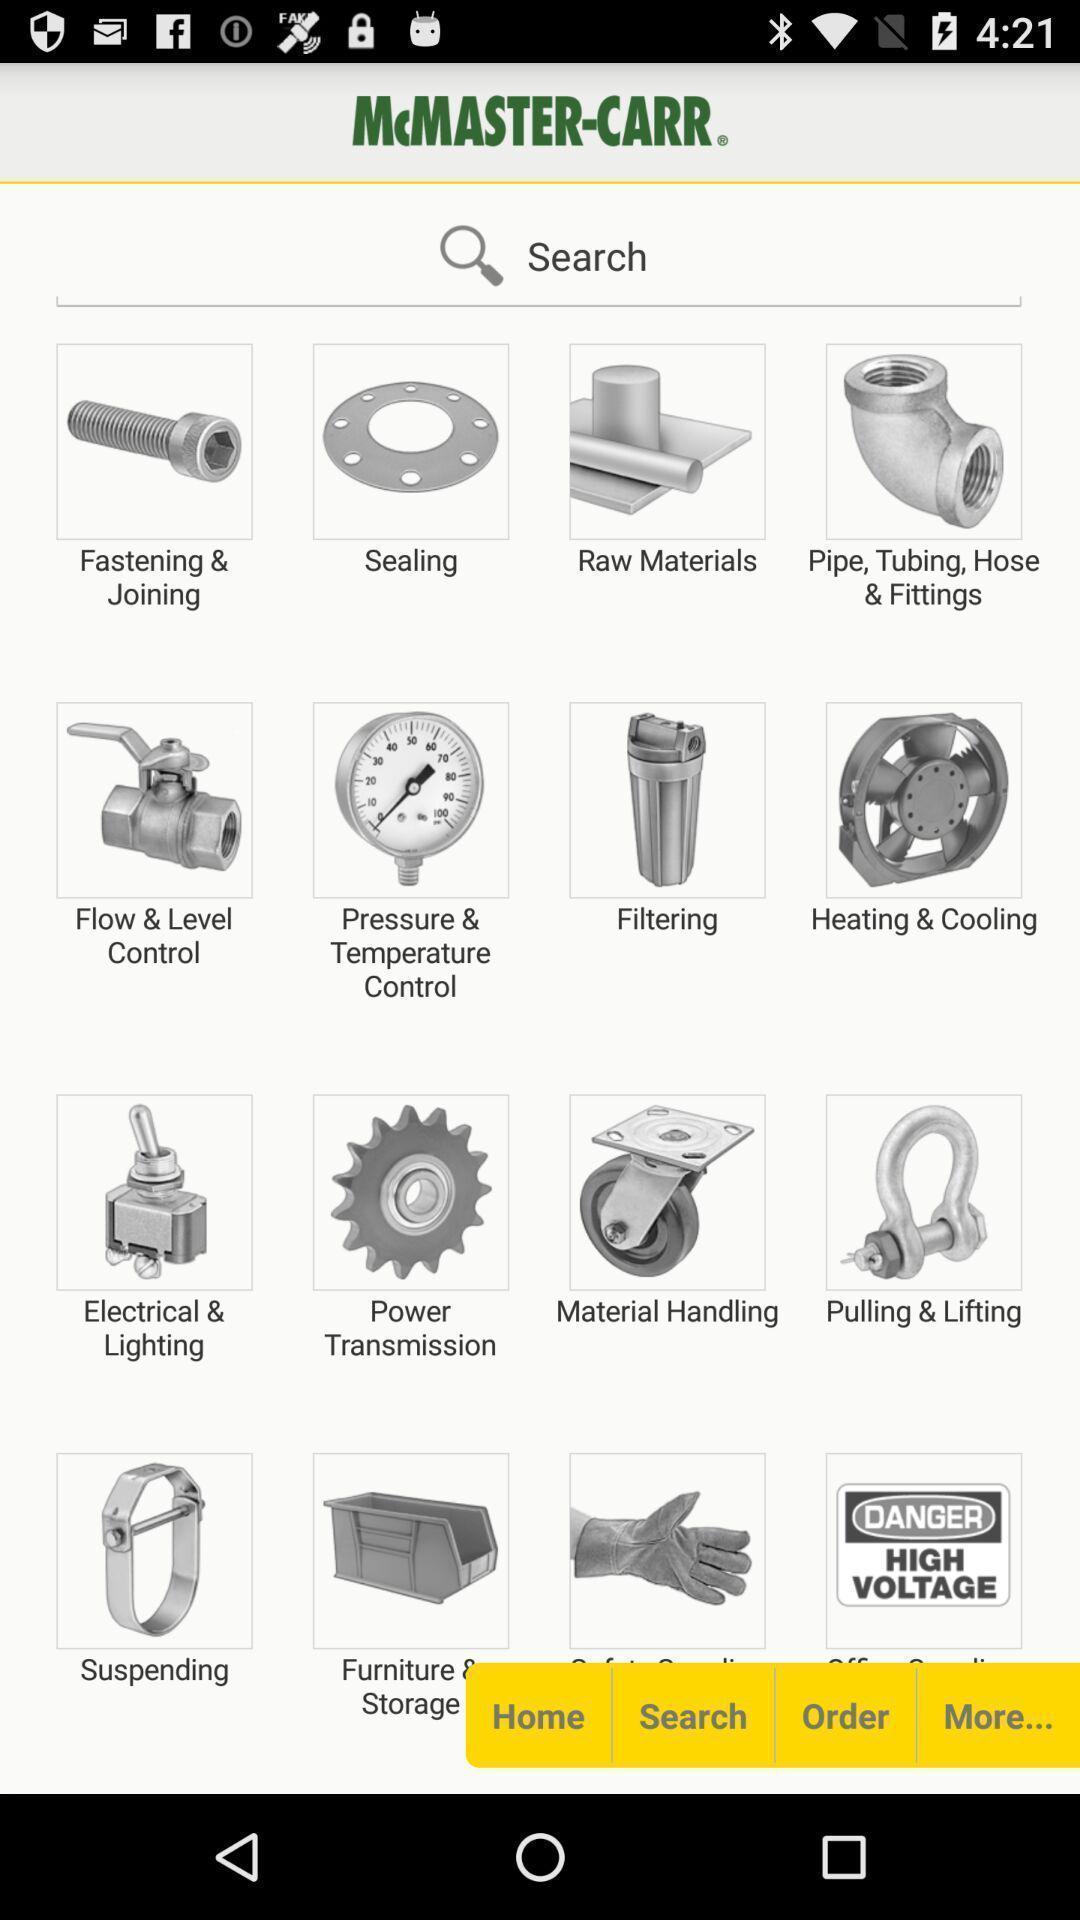Give me a summary of this screen capture. Search page to find various mechanical parts on an app. 